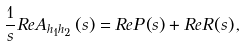<formula> <loc_0><loc_0><loc_500><loc_500>\frac { 1 } { s } R e A _ { h _ { 1 } h _ { 2 } } \left ( s \right ) = R e P \left ( s \right ) + R e R \left ( s \right ) ,</formula> 